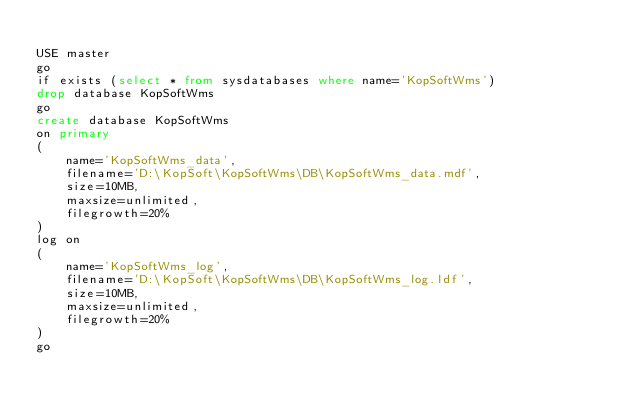Convert code to text. <code><loc_0><loc_0><loc_500><loc_500><_SQL_>
USE master
go
if exists (select * from sysdatabases where name='KopSoftWms')
drop database KopSoftWms
go
create database KopSoftWms
on primary
(
	name='KopSoftWms_data',
	filename='D:\KopSoft\KopSoftWms\DB\KopSoftWms_data.mdf',
	size=10MB,
	maxsize=unlimited,
	filegrowth=20%
)
log on 
(
	name='KopSoftWms_log',
	filename='D:\KopSoft\KopSoftWms\DB\KopSoftWms_log.ldf',
	size=10MB,
	maxsize=unlimited,
	filegrowth=20%
)
go

</code> 